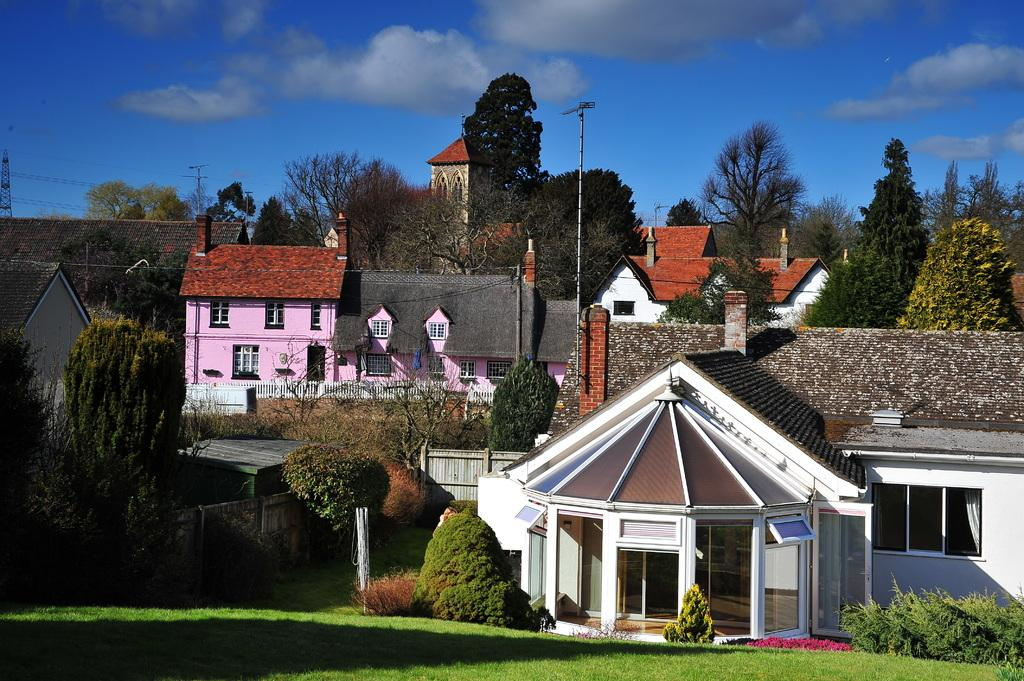What can be seen on the ground in the image? The ground is visible in the image, and there is grass on the ground. What type of vegetation is present in the image? There are green trees in the image. What structures can be seen in the image? There are poles and buildings in the image. What is visible in the background of the image? The sky is visible in the background of the image. How many toes can be seen on the brother's foot in the image? There is no brother or foot present in the image; it features grass, trees, poles, buildings, and the sky. 